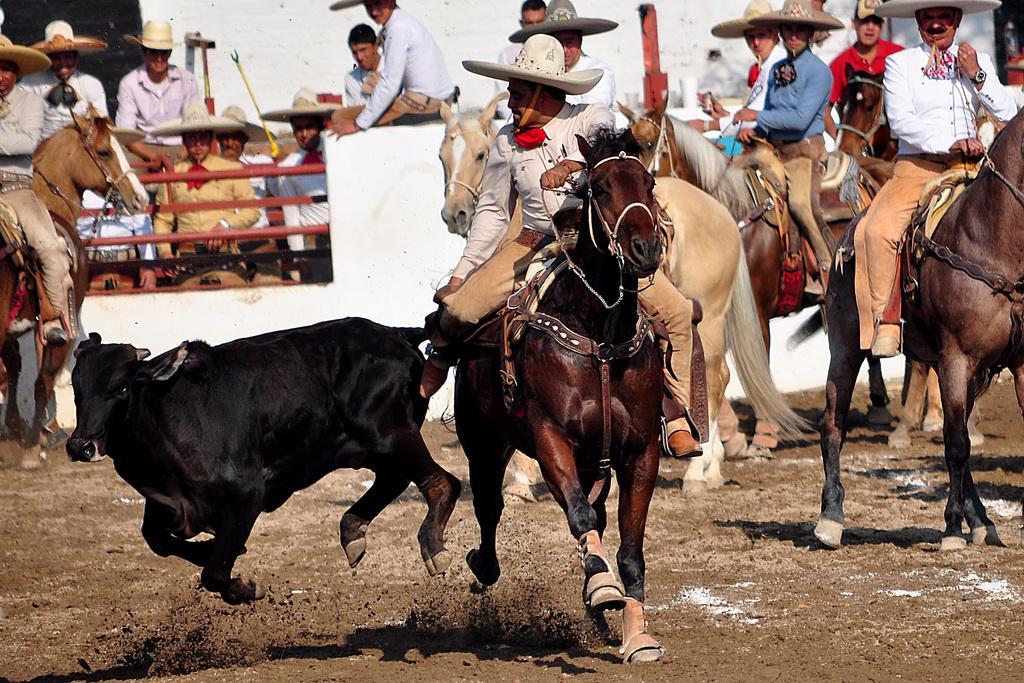Please provide a concise description of this image. This is an outside view. Here I can see few people are wearing white color shirts, caps on the heads and sitting on the horses. On the left side I can see a black color animal which is running. At the bottom of the image I can see the ground. In the background there are few people wearing shirts, caps on their heads, standing and looking at these people. On the top of the image I can see a wall. 